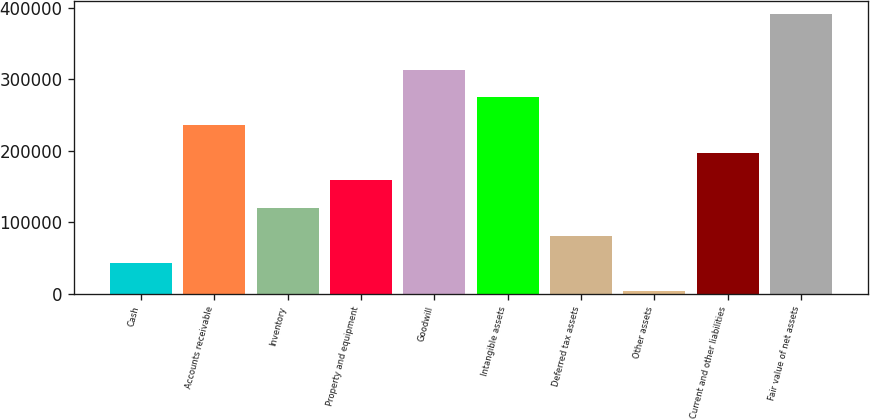Convert chart to OTSL. <chart><loc_0><loc_0><loc_500><loc_500><bar_chart><fcel>Cash<fcel>Accounts receivable<fcel>Inventory<fcel>Property and equipment<fcel>Goodwill<fcel>Intangible assets<fcel>Deferred tax assets<fcel>Other assets<fcel>Current and other liabilities<fcel>Fair value of net assets<nl><fcel>42537.3<fcel>235974<fcel>119912<fcel>158599<fcel>313348<fcel>274661<fcel>81224.6<fcel>3850<fcel>197286<fcel>390723<nl></chart> 